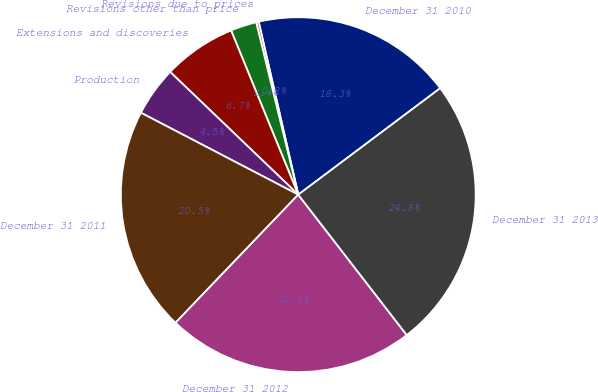<chart> <loc_0><loc_0><loc_500><loc_500><pie_chart><fcel>December 31 2010<fcel>Revisions due to prices<fcel>Revisions other than price<fcel>Extensions and discoveries<fcel>Production<fcel>December 31 2011<fcel>December 31 2012<fcel>December 31 2013<nl><fcel>18.34%<fcel>0.23%<fcel>2.37%<fcel>6.66%<fcel>4.52%<fcel>20.48%<fcel>22.63%<fcel>24.77%<nl></chart> 